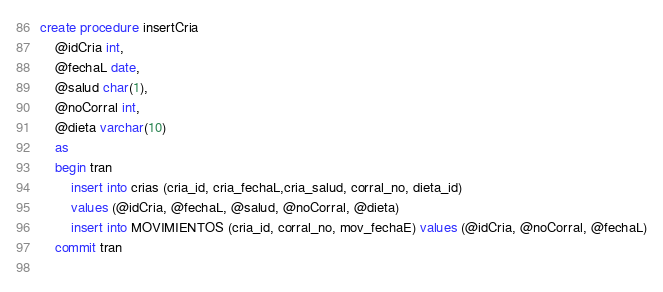<code> <loc_0><loc_0><loc_500><loc_500><_SQL_>create procedure insertCria 
	@idCria int,
	@fechaL date,
	@salud char(1),
	@noCorral int,
	@dieta varchar(10)
	as
	begin tran
		insert into crias (cria_id, cria_fechaL,cria_salud, corral_no, dieta_id) 
		values (@idCria, @fechaL, @salud, @noCorral, @dieta)
		insert into MOVIMIENTOS (cria_id, corral_no, mov_fechaE) values (@idCria, @noCorral, @fechaL)
	commit tran
	
</code> 